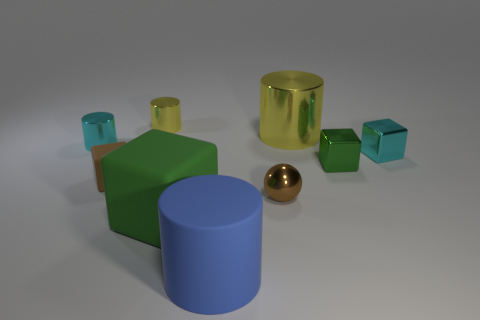Subtract 1 blocks. How many blocks are left? 3 Add 1 green blocks. How many objects exist? 10 Subtract all cylinders. How many objects are left? 5 Subtract 0 red balls. How many objects are left? 9 Subtract all tiny yellow things. Subtract all balls. How many objects are left? 7 Add 7 large green matte blocks. How many large green matte blocks are left? 8 Add 2 green metallic objects. How many green metallic objects exist? 3 